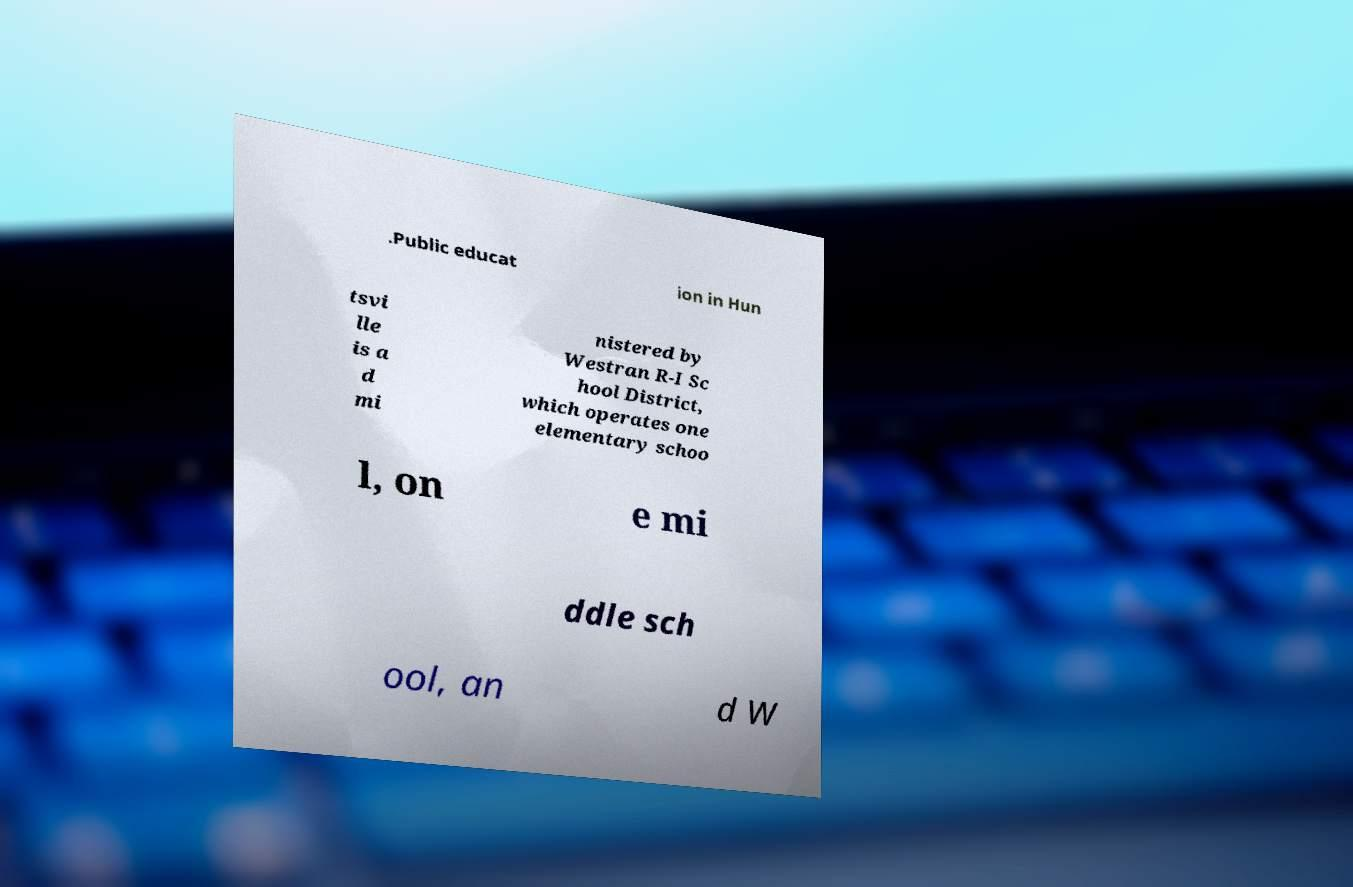What messages or text are displayed in this image? I need them in a readable, typed format. .Public educat ion in Hun tsvi lle is a d mi nistered by Westran R-I Sc hool District, which operates one elementary schoo l, on e mi ddle sch ool, an d W 